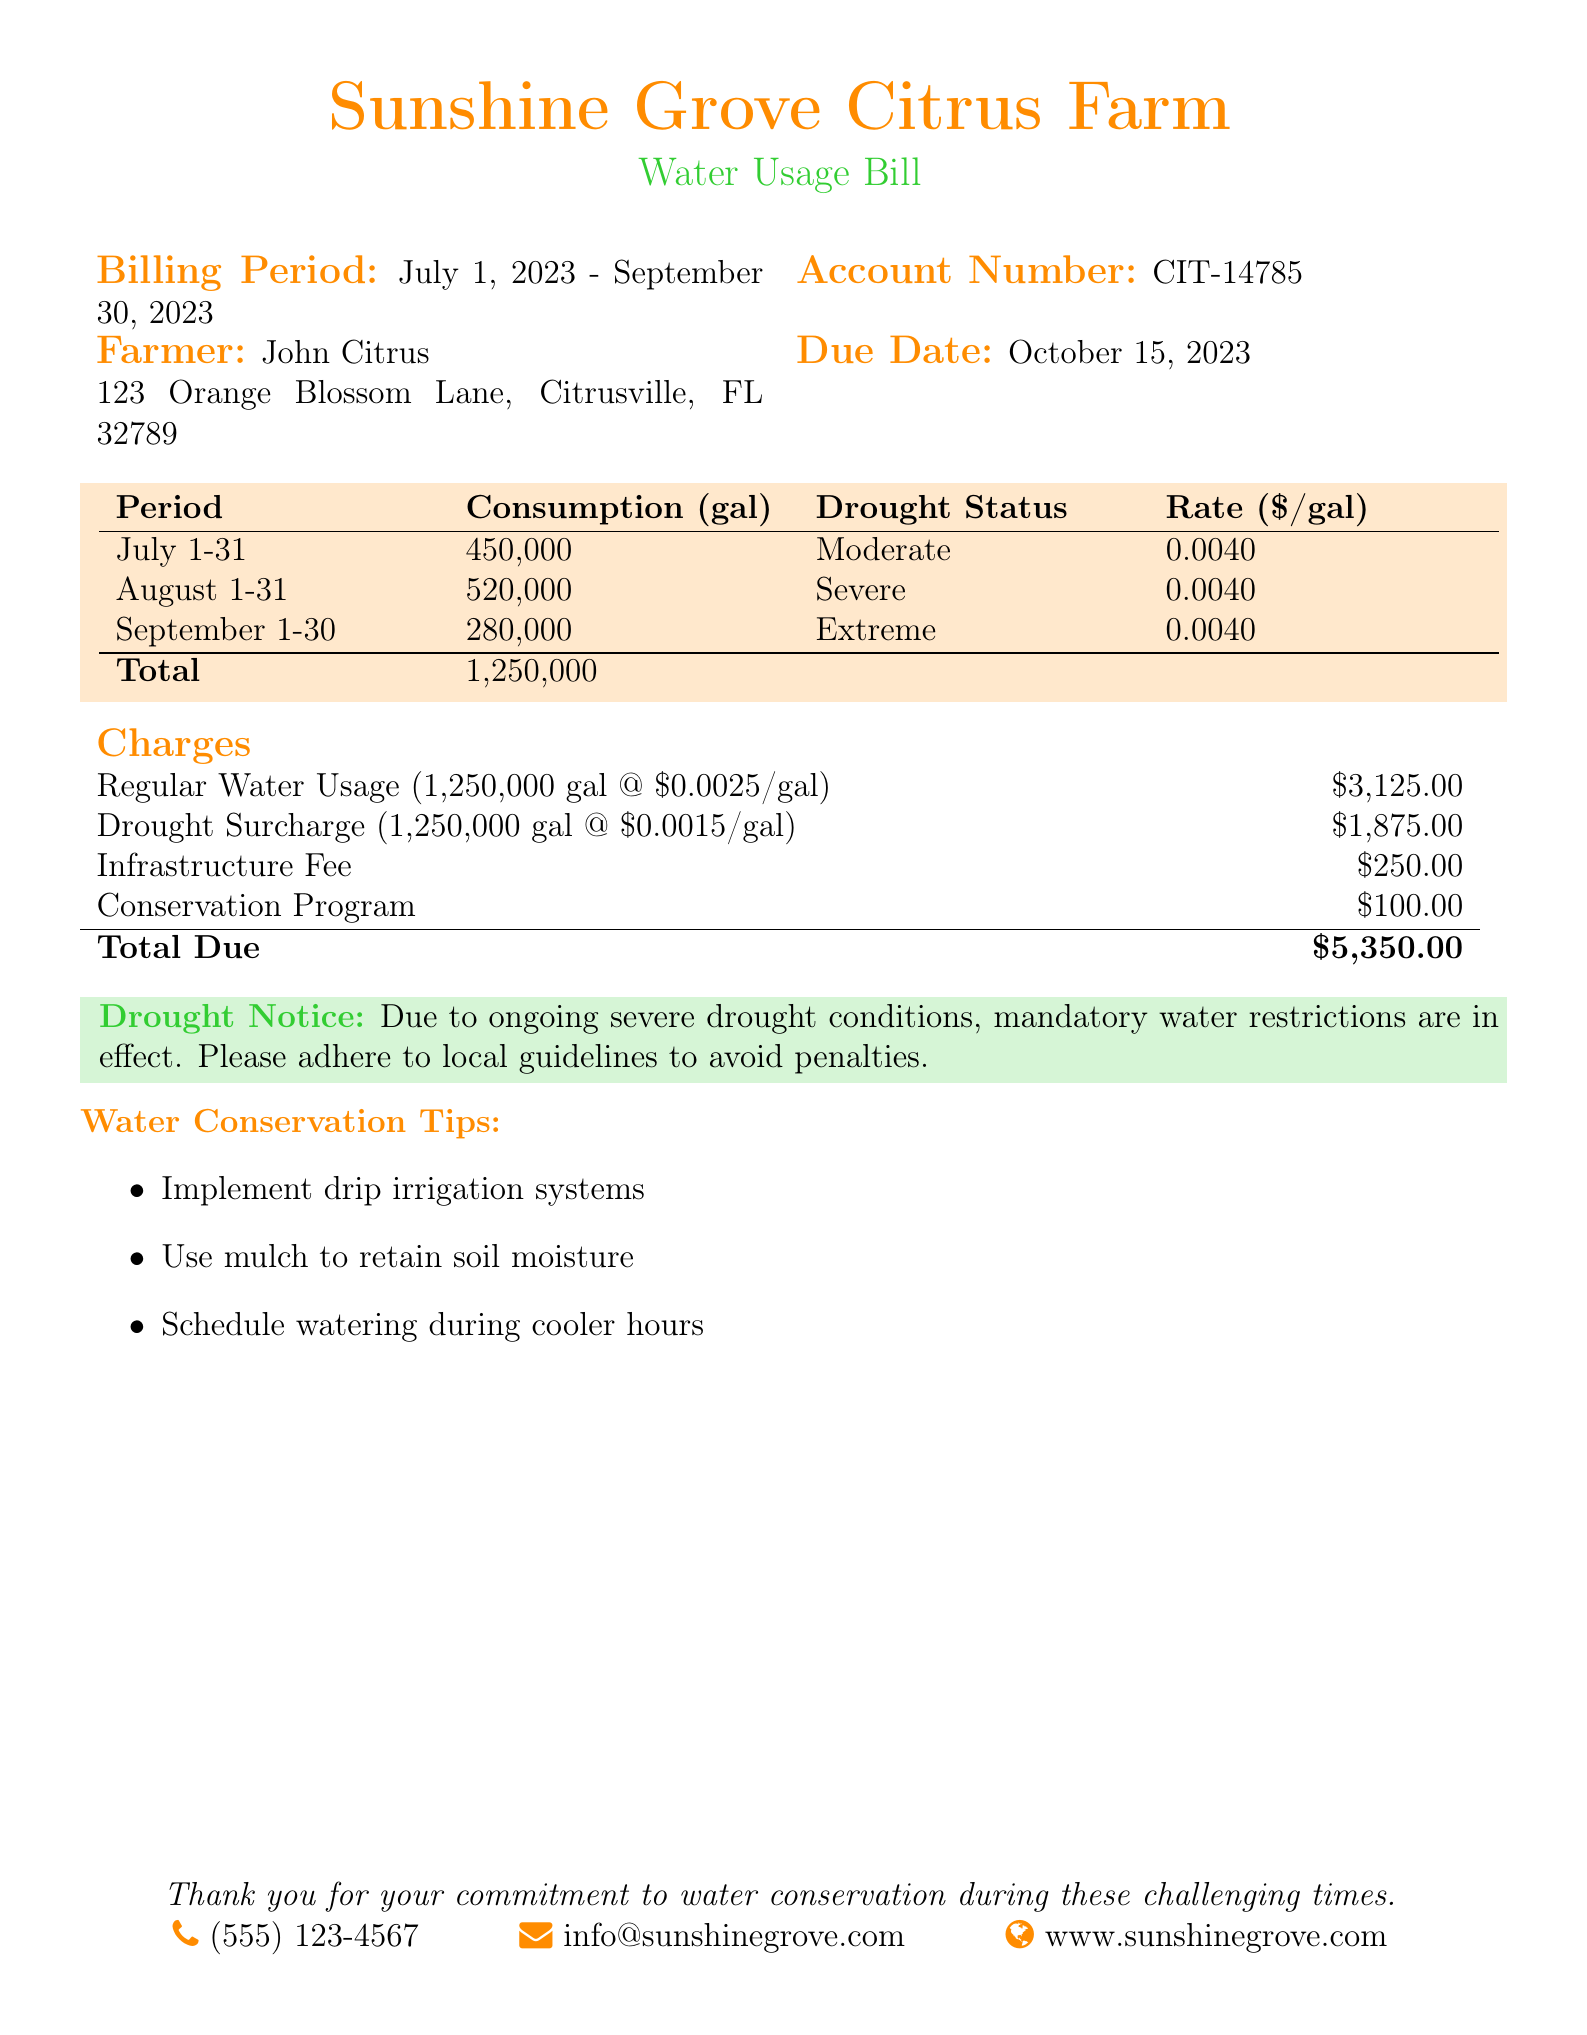What is the account number? The account number is provided in the billing details section of the document.
Answer: CIT-14785 What is the total consumption during the billing period? The total consumption is calculated by summing the water usage across all months in the period.
Answer: 1,250,000 What is the drought status for August? The drought status is mentioned in the period section of the document.
Answer: Severe What is the due date for the bill? The due date is explicitly stated in the billing details section.
Answer: October 15, 2023 What is the infrastructure fee? The infrastructure fee is listed under the charges section of the document.
Answer: $250.00 How much is the drought surcharge per gallon? The drought surcharge is provided in the charges section based on the total consumption.
Answer: $0.0015/gal What conservation program fee is included in the total charges? The fee for the conservation program is explicitly mentioned in the charges table.
Answer: $100.00 What was the total bill amount due? The total bill amount is the final calculation in the charges section of the document.
Answer: $5,350.00 What are three tips provided for water conservation? The document lists several tips for water conservation in a bullet point format.
Answer: Implement drip irrigation systems, Use mulch to retain soil moisture, Schedule watering during cooler hours 